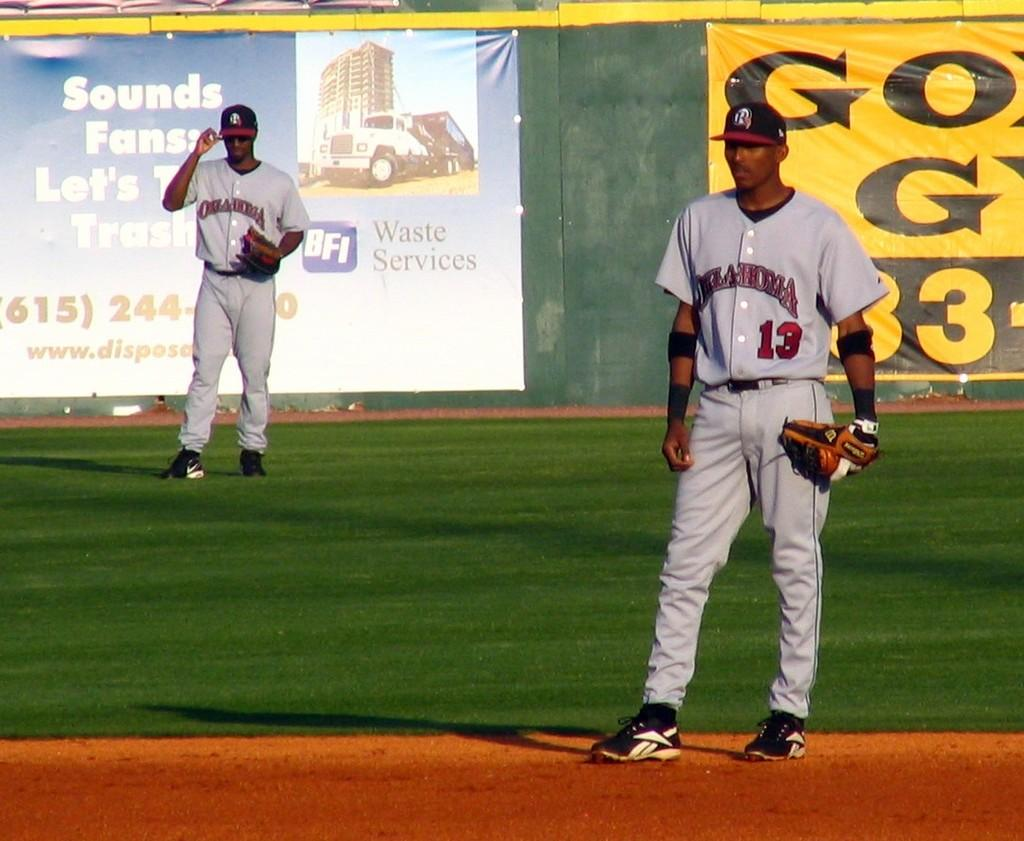<image>
Describe the image concisely. Man wearing a number 13 on his jersey standing and watching on the field. 